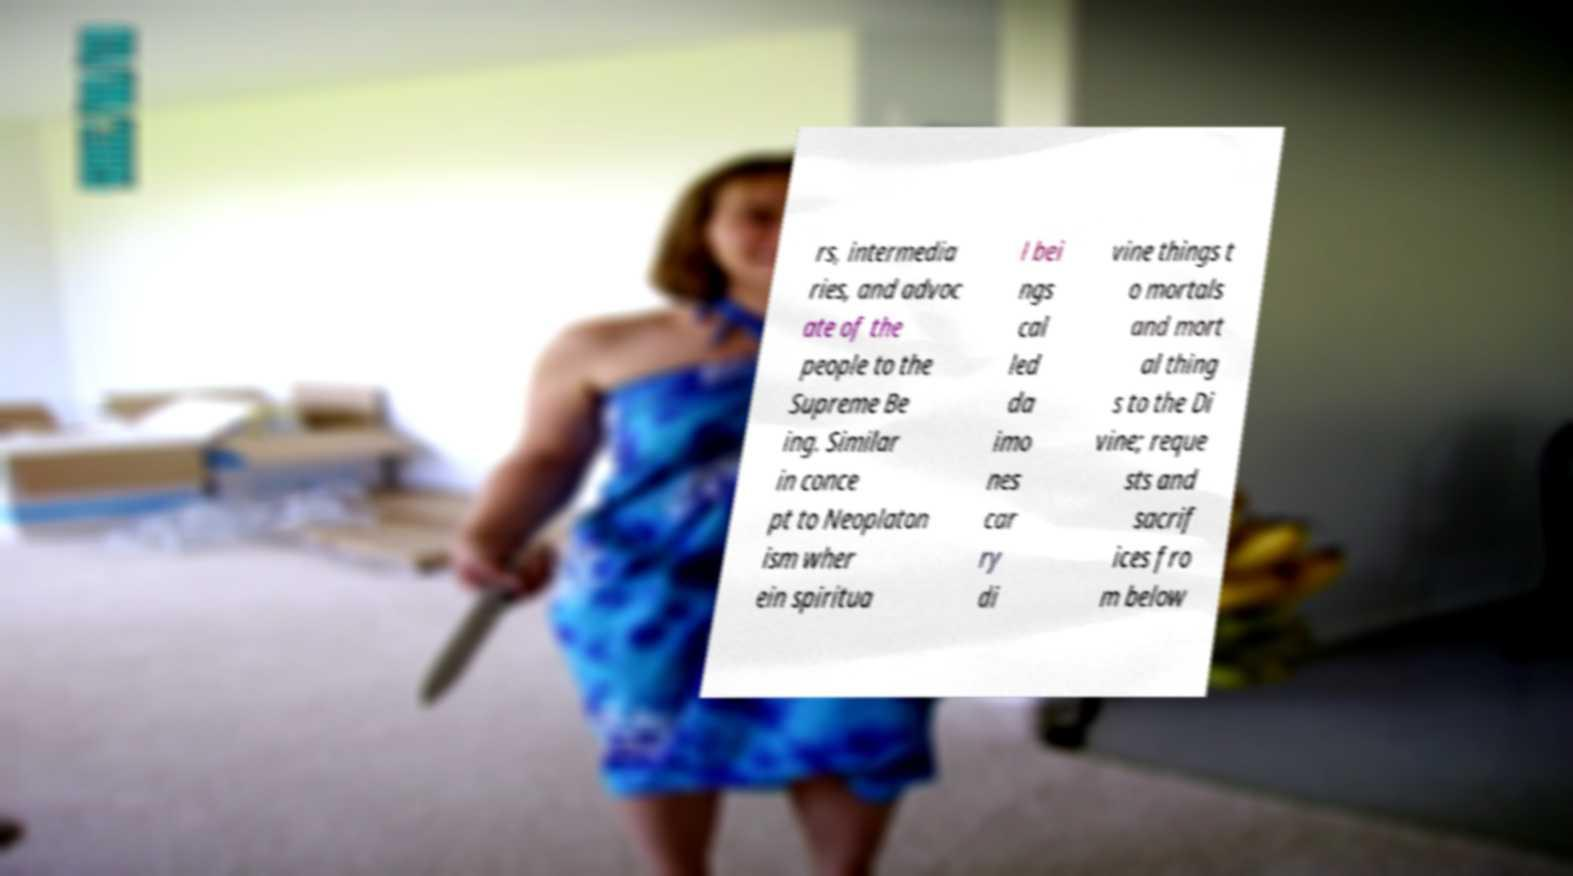Can you accurately transcribe the text from the provided image for me? rs, intermedia ries, and advoc ate of the people to the Supreme Be ing. Similar in conce pt to Neoplaton ism wher ein spiritua l bei ngs cal led da imo nes car ry di vine things t o mortals and mort al thing s to the Di vine; reque sts and sacrif ices fro m below 